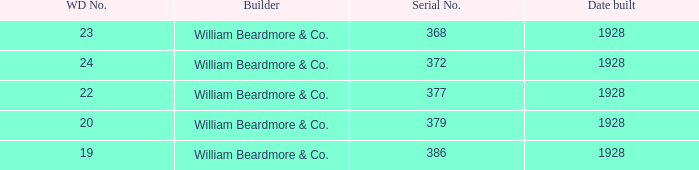Name the builder for serial number being 377 William Beardmore & Co. 